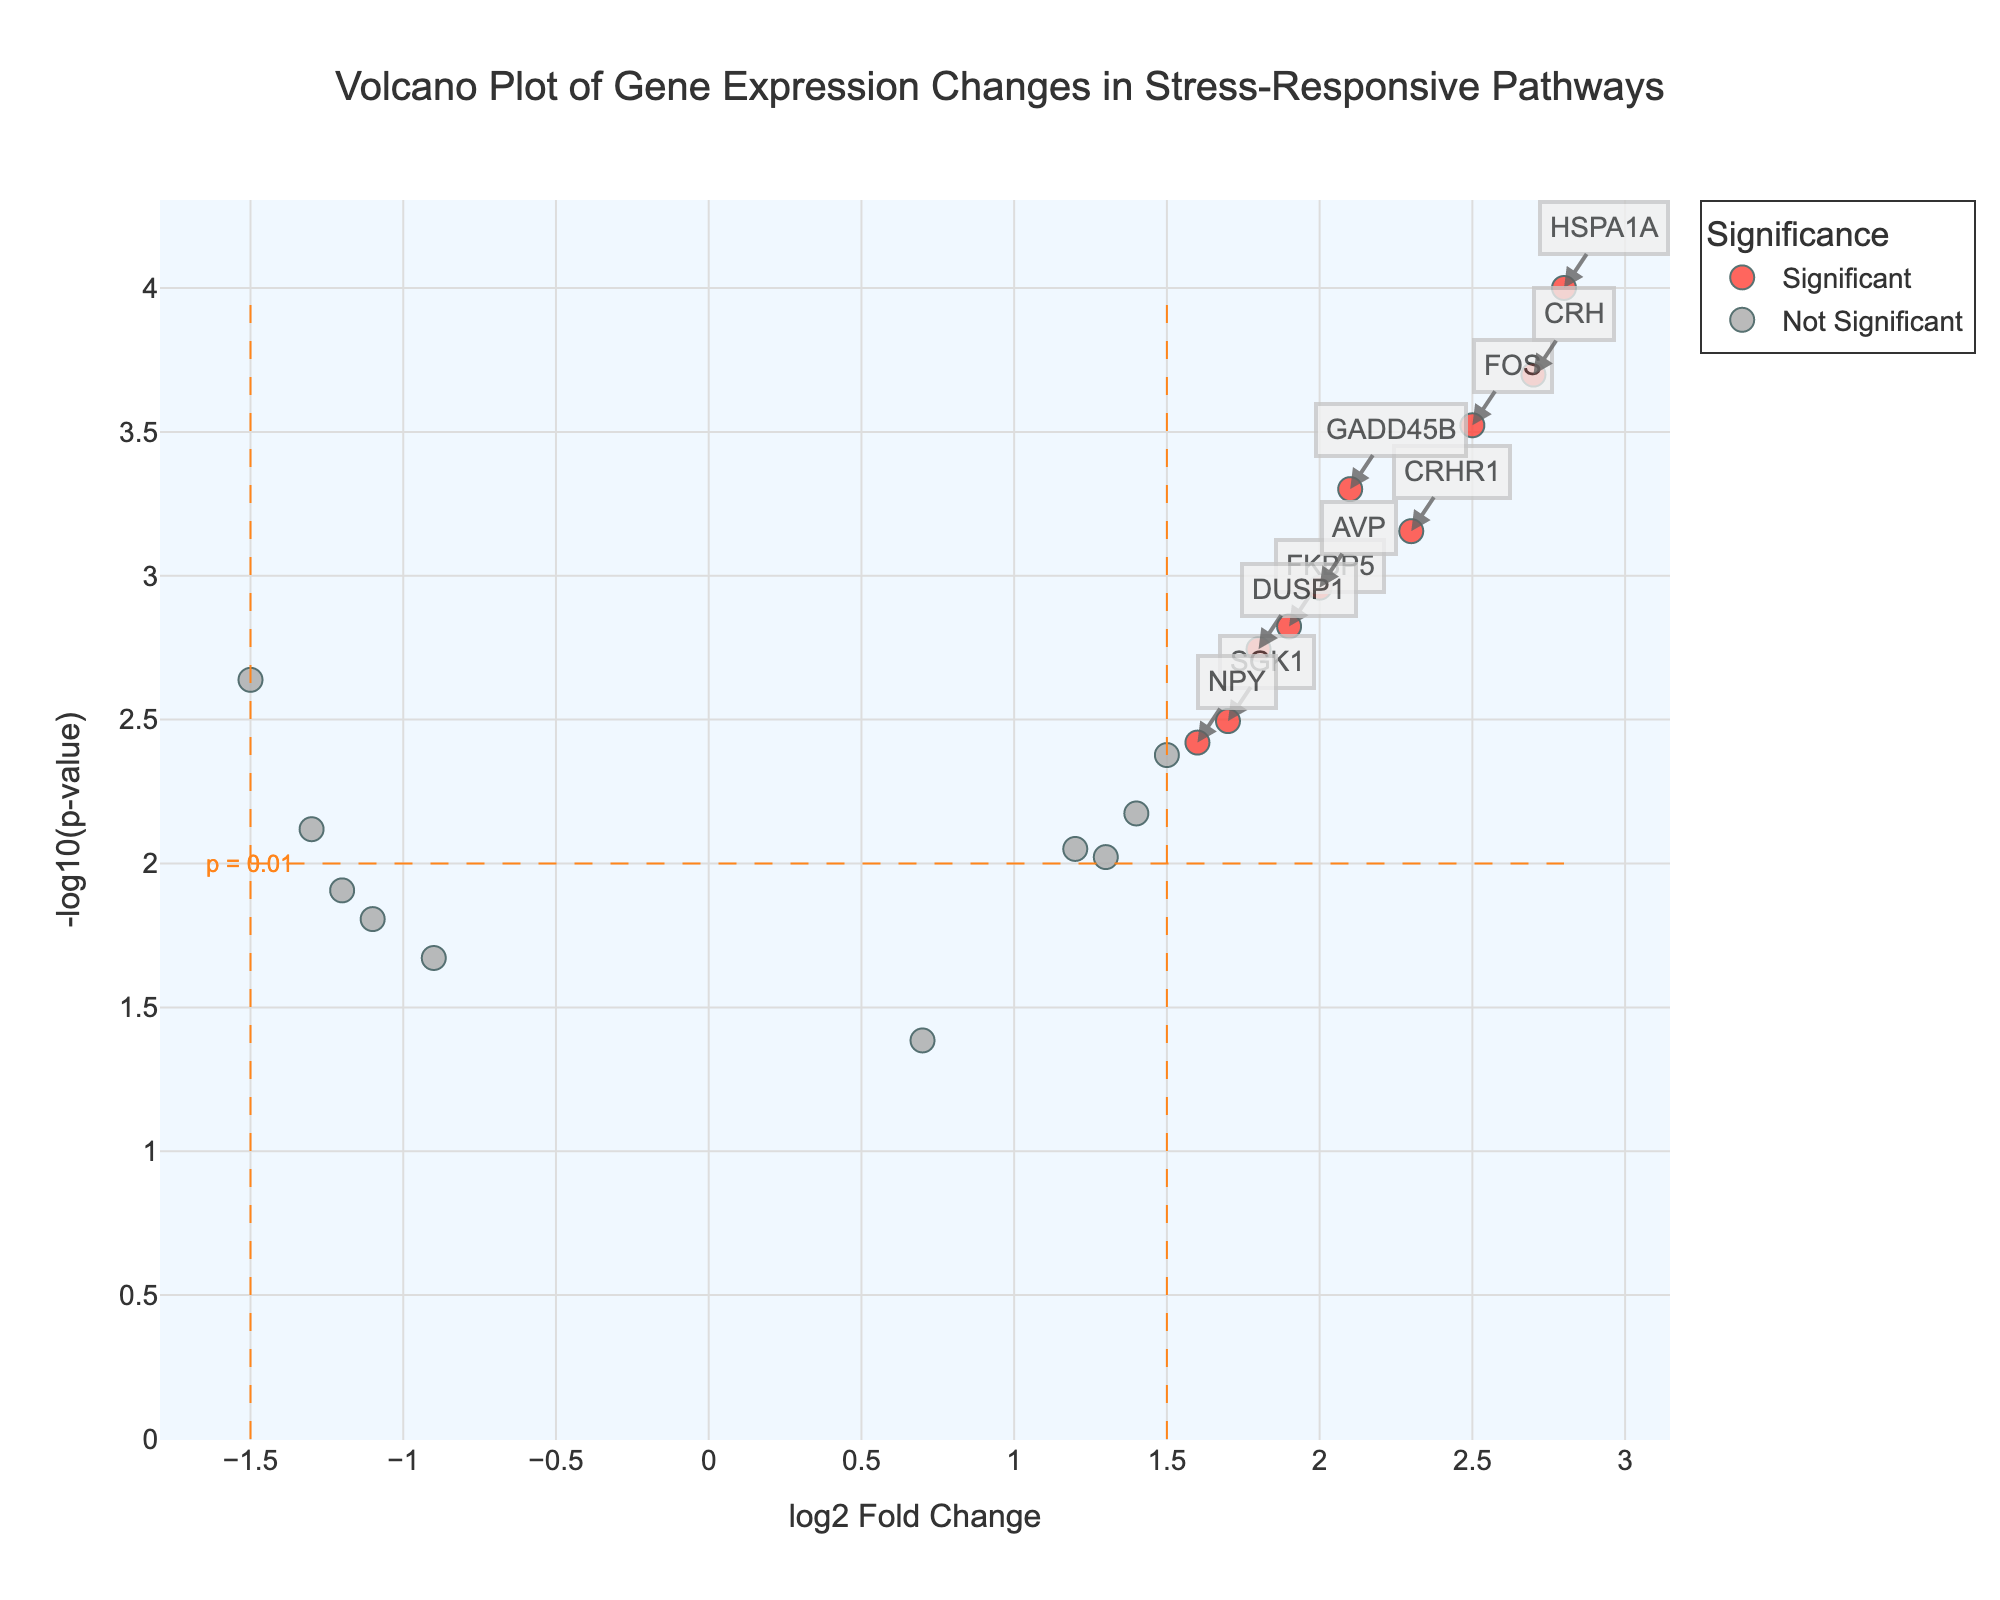What is the title of the volcano plot? The title is usually displayed at the top of the plot, summarizing the nature of the visualization.
Answer: Volcano Plot of Gene Expression Changes in Stress-Responsive Pathways Which gene has the highest log2 Fold Change? By looking at the x-axis and finding the point furthest to the right, we can determine the gene with the highest log2 Fold Change.
Answer: HSPA1A How many data points are considered significant? Significant points are usually color-coded and in this plot, red indicates significance. By counting the red points, we determine the number of significant data points.
Answer: 11 What is the significance threshold for p-value? The threshold for p-value is typically indicated by a horizontal dashed line on a volcano plot.
Answer: 0.01 Which gene is just below the significance threshold? By locating the point closest to the horizontal dashed line marking the p-value threshold, we can identify the gene that falls just below it.
Answer: PER1 Which gene shows the most statistically significant change? The most statistically significant gene will have the highest -log10(p-value), which is determined by the highest point on the y-axis.
Answer: HSPA1A Compare the log2 Fold Change of CRHR1 and FKBP5. Which one is higher? Locate the positions of CRHR1 and FKBP5 on the x-axis, then compare their values. CRHR1 has a higher log2 Fold Change than FKBP5.
Answer: CRHR1 How many genes have a positive log2 Fold Change but are not significant? Identify the gray-colored points on the right side of the y-axis threshold (positive log2 Fold Change) to count the non-significant genes.
Answer: 4 What are the coordinates for the gene FOS? Find the position of the gene label 'FOS' on the plot, noting its log2 Fold Change on the x-axis and -log10(p-value) on the y-axis.
Answer: (2.5, 3.52) Are there more upregulated or downregulated significant genes? Upregulated genes have positive log2 Fold Change, while downregulated genes have negative. Count the red points on either side to see which group is larger.
Answer: More upregulated 